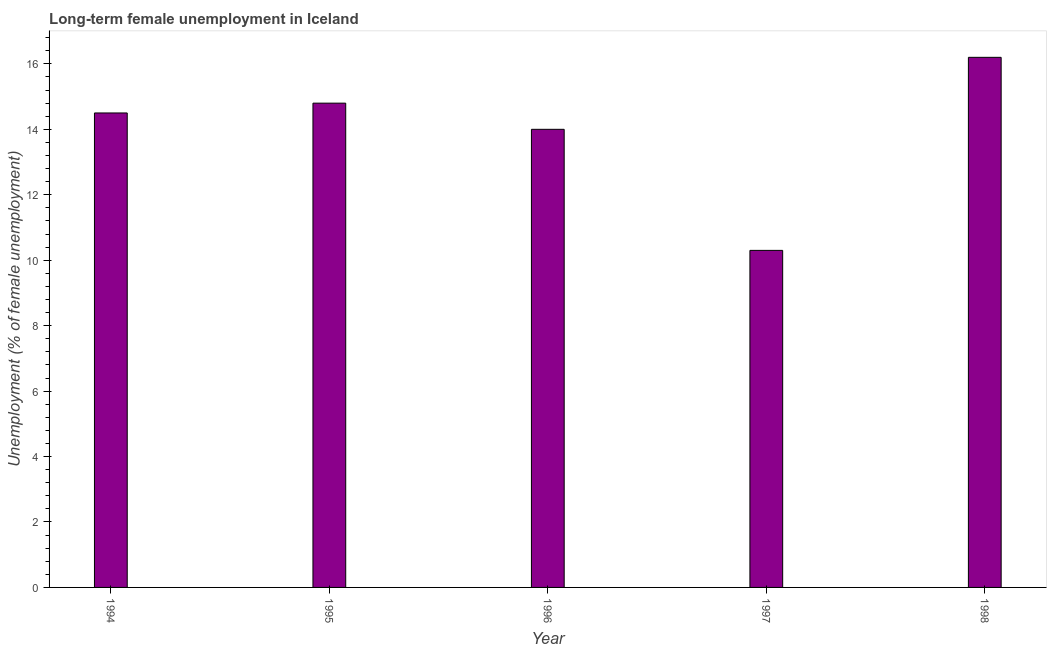Does the graph contain any zero values?
Provide a succinct answer. No. Does the graph contain grids?
Provide a succinct answer. No. What is the title of the graph?
Your response must be concise. Long-term female unemployment in Iceland. What is the label or title of the X-axis?
Your response must be concise. Year. What is the label or title of the Y-axis?
Keep it short and to the point. Unemployment (% of female unemployment). Across all years, what is the maximum long-term female unemployment?
Offer a terse response. 16.2. Across all years, what is the minimum long-term female unemployment?
Give a very brief answer. 10.3. What is the sum of the long-term female unemployment?
Keep it short and to the point. 69.8. What is the difference between the long-term female unemployment in 1995 and 1998?
Ensure brevity in your answer.  -1.4. What is the average long-term female unemployment per year?
Offer a terse response. 13.96. In how many years, is the long-term female unemployment greater than 6 %?
Provide a succinct answer. 5. What is the ratio of the long-term female unemployment in 1994 to that in 1998?
Give a very brief answer. 0.9. Is the long-term female unemployment in 1994 less than that in 1998?
Your answer should be compact. Yes. Is the difference between the long-term female unemployment in 1994 and 1995 greater than the difference between any two years?
Your answer should be compact. No. What is the difference between the highest and the second highest long-term female unemployment?
Offer a very short reply. 1.4. Is the sum of the long-term female unemployment in 1994 and 1996 greater than the maximum long-term female unemployment across all years?
Offer a very short reply. Yes. How many bars are there?
Your answer should be compact. 5. How many years are there in the graph?
Your answer should be very brief. 5. What is the difference between two consecutive major ticks on the Y-axis?
Your response must be concise. 2. What is the Unemployment (% of female unemployment) of 1995?
Offer a terse response. 14.8. What is the Unemployment (% of female unemployment) in 1996?
Give a very brief answer. 14. What is the Unemployment (% of female unemployment) of 1997?
Give a very brief answer. 10.3. What is the Unemployment (% of female unemployment) in 1998?
Your answer should be very brief. 16.2. What is the difference between the Unemployment (% of female unemployment) in 1994 and 1996?
Give a very brief answer. 0.5. What is the difference between the Unemployment (% of female unemployment) in 1994 and 1998?
Give a very brief answer. -1.7. What is the difference between the Unemployment (% of female unemployment) in 1995 and 1997?
Your answer should be very brief. 4.5. What is the difference between the Unemployment (% of female unemployment) in 1995 and 1998?
Your response must be concise. -1.4. What is the difference between the Unemployment (% of female unemployment) in 1996 and 1997?
Your answer should be very brief. 3.7. What is the difference between the Unemployment (% of female unemployment) in 1997 and 1998?
Provide a short and direct response. -5.9. What is the ratio of the Unemployment (% of female unemployment) in 1994 to that in 1995?
Ensure brevity in your answer.  0.98. What is the ratio of the Unemployment (% of female unemployment) in 1994 to that in 1996?
Provide a short and direct response. 1.04. What is the ratio of the Unemployment (% of female unemployment) in 1994 to that in 1997?
Ensure brevity in your answer.  1.41. What is the ratio of the Unemployment (% of female unemployment) in 1994 to that in 1998?
Give a very brief answer. 0.9. What is the ratio of the Unemployment (% of female unemployment) in 1995 to that in 1996?
Ensure brevity in your answer.  1.06. What is the ratio of the Unemployment (% of female unemployment) in 1995 to that in 1997?
Provide a short and direct response. 1.44. What is the ratio of the Unemployment (% of female unemployment) in 1995 to that in 1998?
Give a very brief answer. 0.91. What is the ratio of the Unemployment (% of female unemployment) in 1996 to that in 1997?
Give a very brief answer. 1.36. What is the ratio of the Unemployment (% of female unemployment) in 1996 to that in 1998?
Provide a short and direct response. 0.86. What is the ratio of the Unemployment (% of female unemployment) in 1997 to that in 1998?
Make the answer very short. 0.64. 